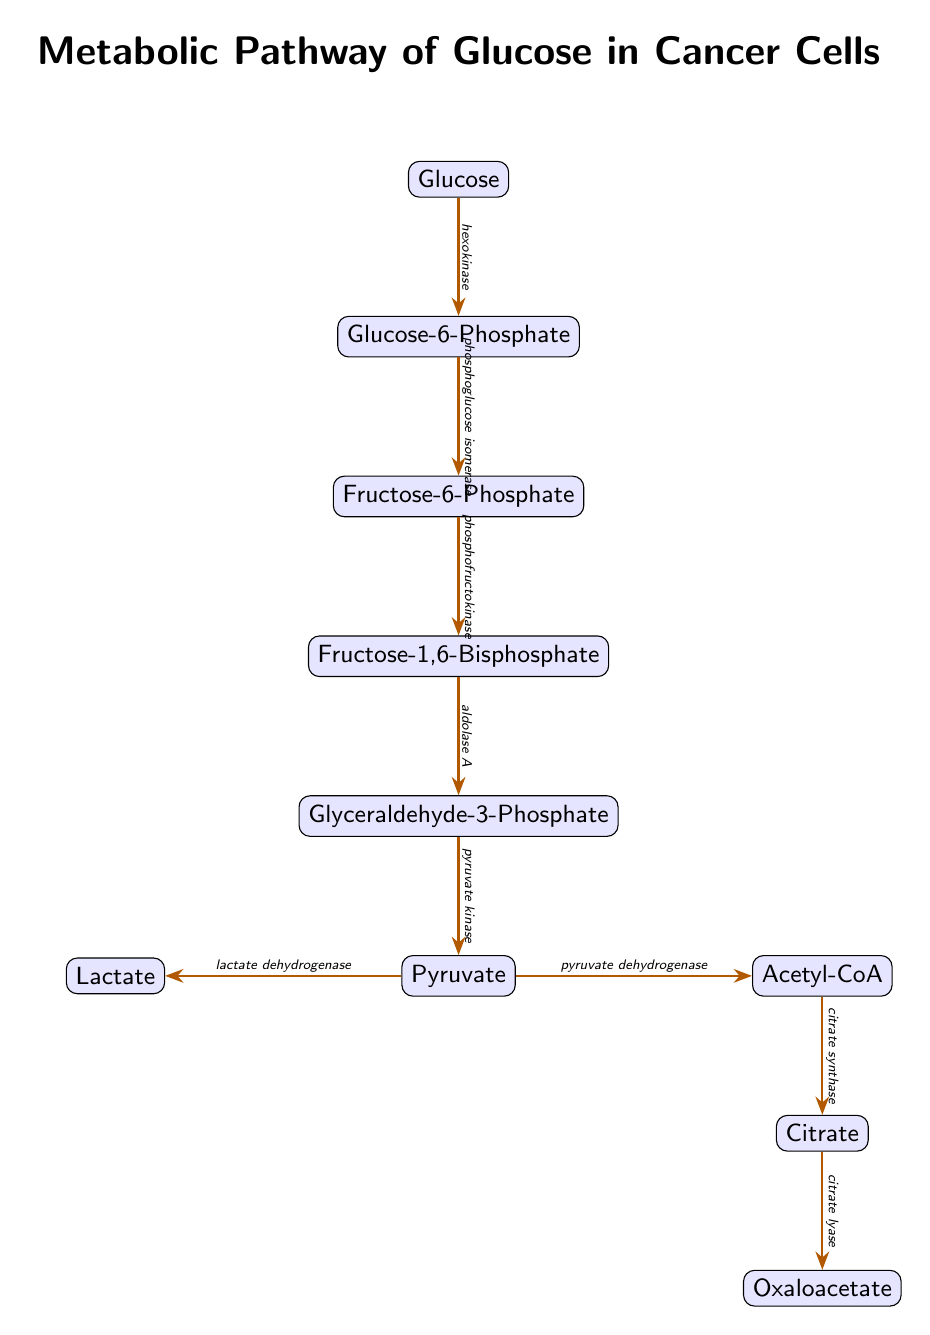What is the first metabolite in the pathway? The first metabolite in the pathway is indicated at the top of the diagram; it shows "Glucose" as the starting point of the metabolic process.
Answer: Glucose What enzyme is responsible for converting Glucose to Glucose-6-Phosphate? The diagram shows an arrow from Glucose to Glucose-6-Phosphate, with "hexokinase" labeled as the enzyme facilitating this conversion.
Answer: hexokinase How many metabolites are present in the pathway? By counting the metabolite nodes in the diagram, there are a total of 8 distinct metabolites listed, starting from Glucose and ending with Oxaloacetate.
Answer: 8 What enzyme follows the conversion of Fructose-6-Phosphate? The diagram indicates an arrow from Fructose-6-Phosphate to Fructose-1,6-Bisphosphate, with "phosphofructokinase" labeled as the enzyme that comes next after Fructose-6-Phosphate.
Answer: phosphofructokinase What is the final metabolite produced from Acetyl-CoA? The diagram shows that Acetyl-CoA is converted to Citrate, suggesting that Citrate is the metabolite that follows Acetyl-CoA in the metabolic pathway.
Answer: Citrate Which enzyme leads to the production of Lactate from Pyruvate? The arrow from Pyruvate to Lactate is accompanied by the label "lactate dehydrogenase," indicating that this enzyme is responsible for the conversion of Pyruvate to Lactate.
Answer: lactate dehydrogenase What is the common pathway for Pyruvate in cancer cells? Based on the diagram, Pyruvate splits into two possible pathways leading to either Lactate via lactate dehydrogenase or Acetyl-CoA via pyruvate dehydrogenase, showcasing the dual fate of Pyruvate in cancer metabolism.
Answer: Lactate and Acetyl-CoA Which enzyme acts on Fructose-1,6-Bisphosphate to produce Glyceraldehyde-3-Phosphate? The diagram explicitly states that "aldolase A" is the enzyme that catalyzes the conversion of Fructose-1,6-Bisphosphate to Glyceraldehyde-3-Phosphate.
Answer: aldolase A In the context of a cancer cell, what is the significance of the pathway depicted? The pathway illustrates altered glucose metabolism commonly seen in cancer cells, wherein there's a preferential conversion of glucose to lactate even in the presence of oxygen, known as the Warburg effect.
Answer: Warburg effect 